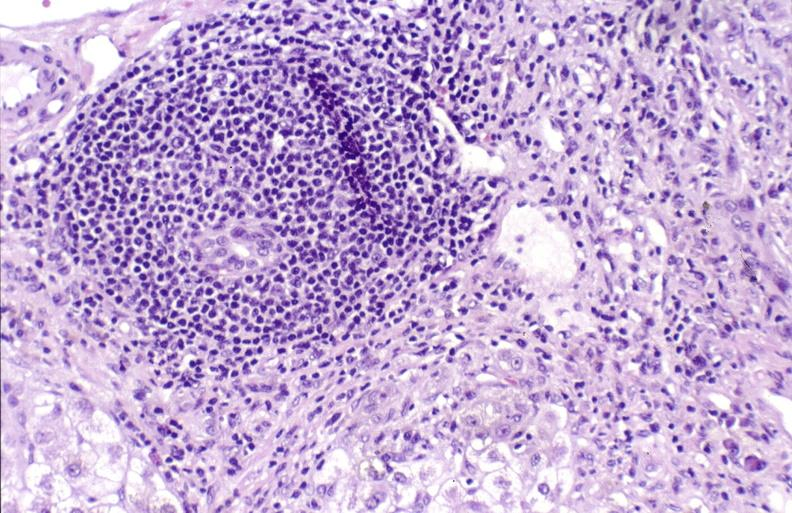s aldehyde fuscin present?
Answer the question using a single word or phrase. No 